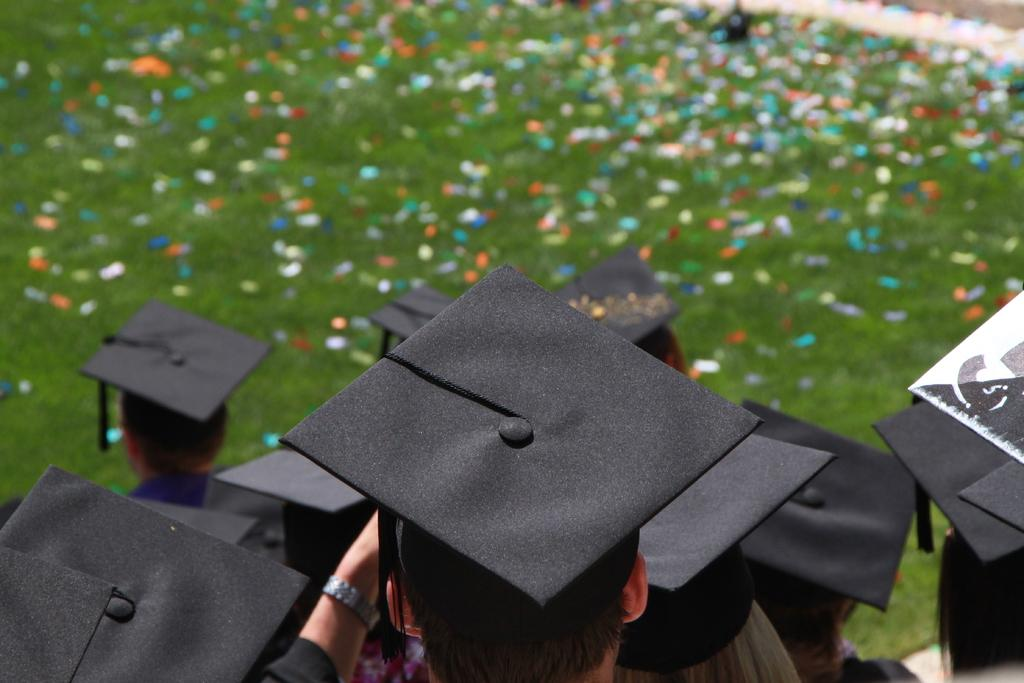How many people are in the image? There is a group of people in the image. What are the people wearing on their heads? The people are wearing black hats. What color is the background of the image? The background of the image is green. What can be seen in the background besides the green color? There are color papers in the background of the image. What type of animal is sitting on the person's shoulder in the image? There is no animal present in the image; the people are wearing black hats and standing in front of a green background with color papers. 